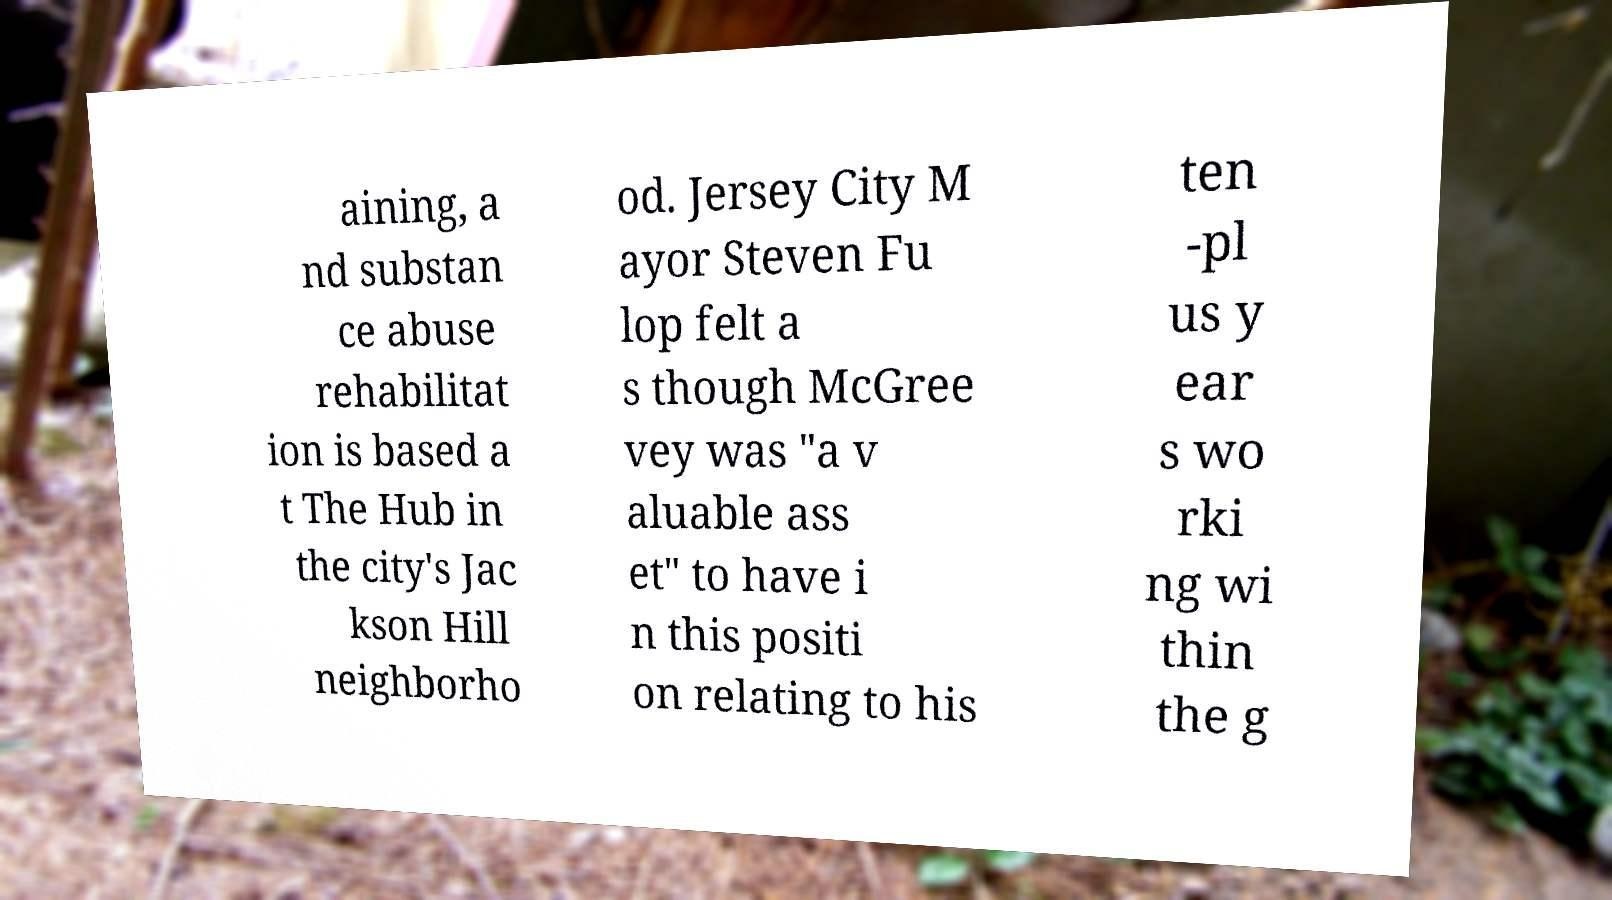Could you assist in decoding the text presented in this image and type it out clearly? aining, a nd substan ce abuse rehabilitat ion is based a t The Hub in the city's Jac kson Hill neighborho od. Jersey City M ayor Steven Fu lop felt a s though McGree vey was "a v aluable ass et" to have i n this positi on relating to his ten -pl us y ear s wo rki ng wi thin the g 